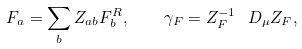Convert formula to latex. <formula><loc_0><loc_0><loc_500><loc_500>F _ { a } = \sum _ { b } Z _ { a b } F _ { b } ^ { R } , \quad \gamma _ { F } = Z _ { F } ^ { - 1 } \ D _ { \mu } Z _ { F } ,</formula> 